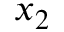Convert formula to latex. <formula><loc_0><loc_0><loc_500><loc_500>x _ { 2 }</formula> 